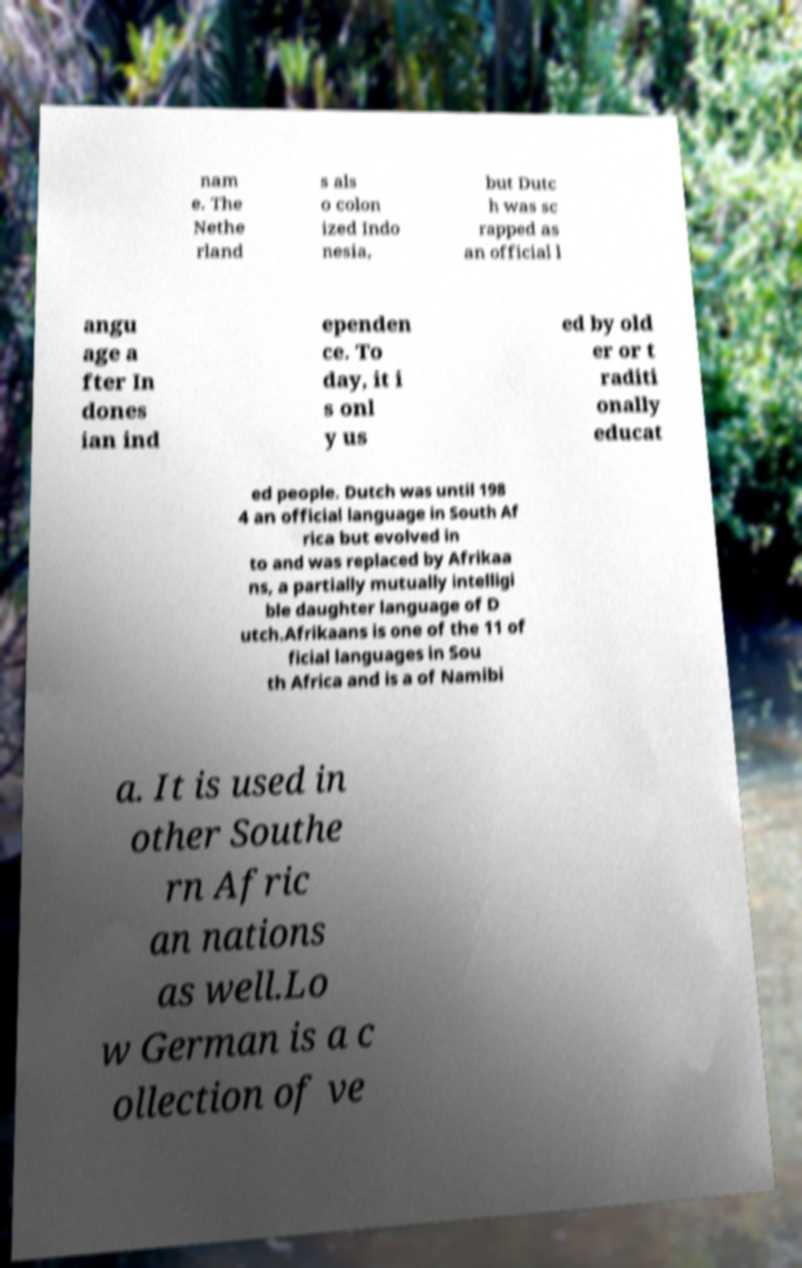Please identify and transcribe the text found in this image. nam e. The Nethe rland s als o colon ized Indo nesia, but Dutc h was sc rapped as an official l angu age a fter In dones ian ind ependen ce. To day, it i s onl y us ed by old er or t raditi onally educat ed people. Dutch was until 198 4 an official language in South Af rica but evolved in to and was replaced by Afrikaa ns, a partially mutually intelligi ble daughter language of D utch.Afrikaans is one of the 11 of ficial languages in Sou th Africa and is a of Namibi a. It is used in other Southe rn Afric an nations as well.Lo w German is a c ollection of ve 